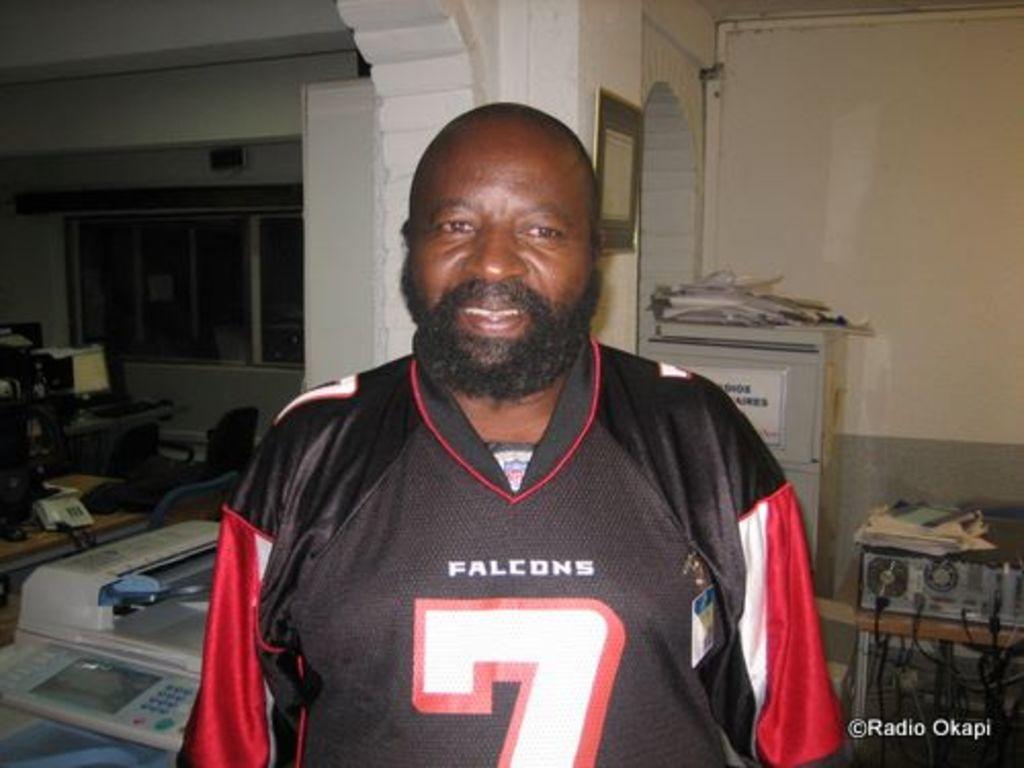What team jersey is this man wearing?
Your response must be concise. Falcons. What number is on his jersey?
Your response must be concise. 7. 